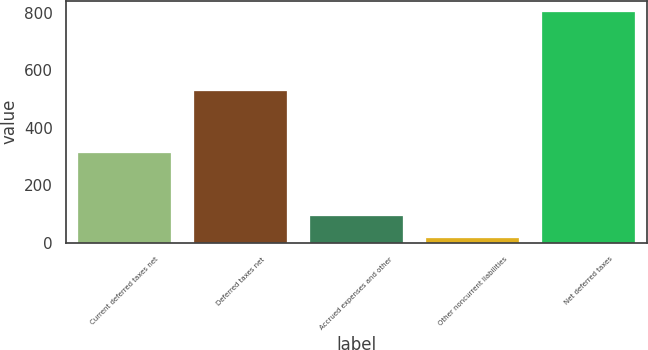Convert chart. <chart><loc_0><loc_0><loc_500><loc_500><bar_chart><fcel>Current deferred taxes net<fcel>Deferred taxes net<fcel>Accrued expenses and other<fcel>Other noncurrent liabilities<fcel>Net deferred taxes<nl><fcel>311<fcel>530<fcel>94.7<fcel>16<fcel>803<nl></chart> 